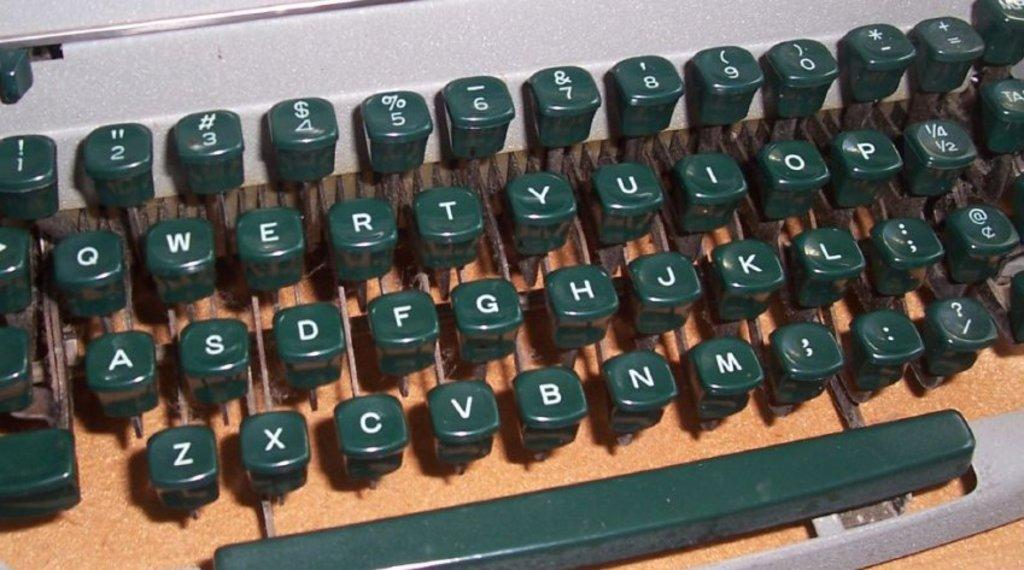<image>
Share a concise interpretation of the image provided. an old fashioned typewriter key board with keys for Q and W 